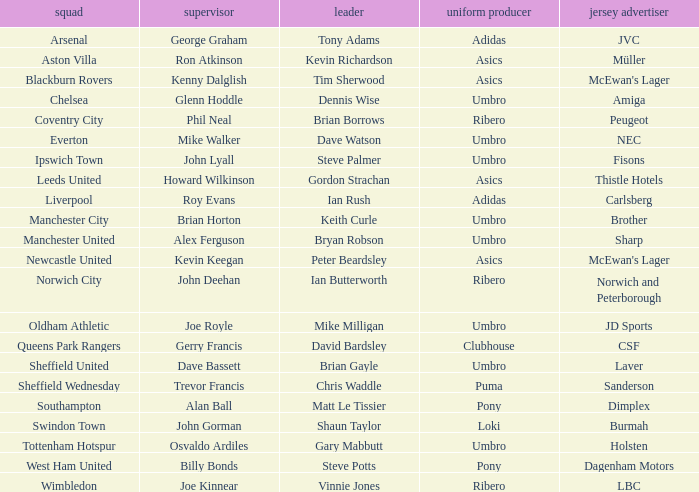What is the kit manufacturer that has billy bonds as the manager? Pony. 